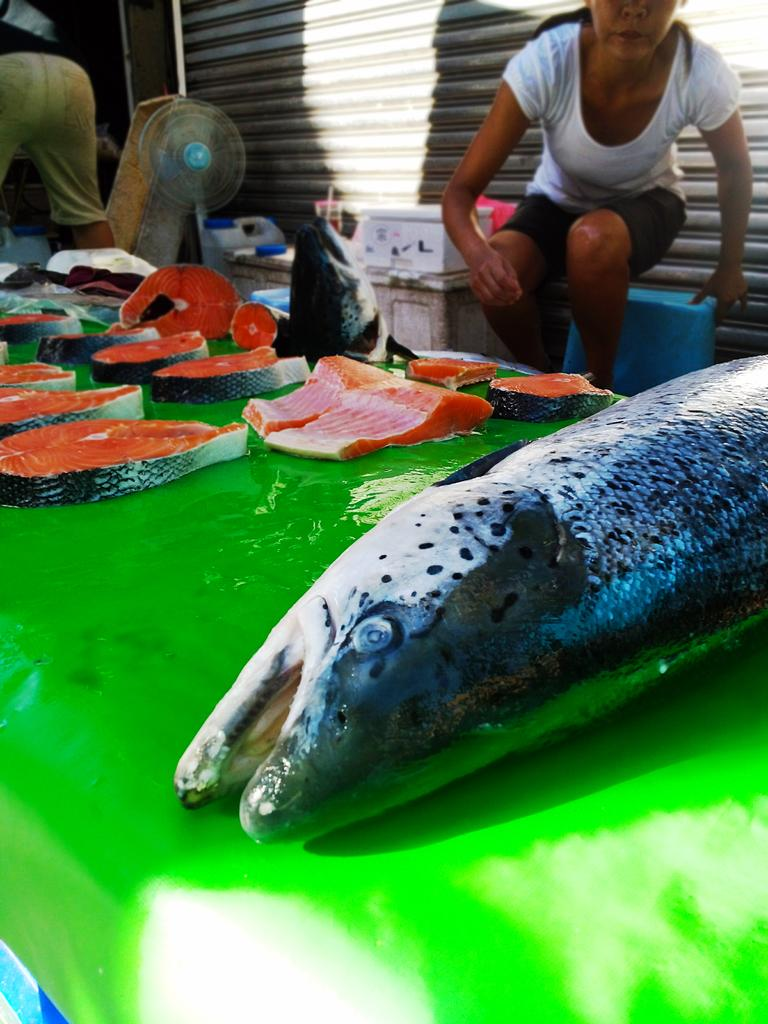What is the main object in the image? There is a table in the image. What is on top of the table? There are fish on the table. Are there any fish-related items beside the fish? Yes, there are fish pieces beside the fish. Can you describe the person in the image? There is a person in the image, but no specific details about them are provided. What is the purpose of the fan in the image? The purpose of the fan in the image is not specified. What other unspecified things can be seen in the image? There are other unspecified things in the image, but no details are provided. How does the cactus balance on the table in the image? There is no cactus present in the image. What nerve is responsible for the person's ability to hold the fish in the image? The image does not provide any information about the person's nerves or their ability to hold the fish. 